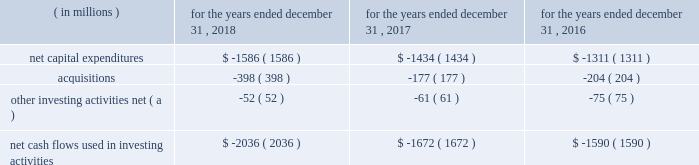In 2017 , cash flows provided by operations increased $ 160 million , primarily due to an increase in net income after non-cash adjustments , including the impact of the enactment of the tcja , and an increase in cash flows from working capital .
The main factors contributing to the net income increase are described in the 201cconsolidated results of operations 201d section and include higher operating revenues , partially offset by higher income taxes due to a $ 125 million re-measurement charge resulting from the impact of the change in the federal tax rate on the company 2019s deferred income taxes from the enactment of the tcja .
The increase in non-cash activities was mainly attributable to the increase in deferred income taxes , as mentioned above , and an increase in depreciation and amortization due to additional utility plant placed in service .
The change in working capital was principally due to ( i ) the timing of accounts payable and accrued liabilities , including the accrual recorded during 2016 for the binding global agreement in principle to settle claims associated with the freedom industries chemical spill in west virginia , ( ii ) a decrease in unbilled revenues as a result of our military services group achieving significant capital project milestones during 2016 , and ( iii ) a change in other current assets and liabilities , including the decrease in other current assets associated with the termination of our four forward starting swap agreements and timing of payments clearing our cash accounts .
The company expects to make pension contributions to the plan trusts of up to $ 31 million in 2019 .
In addition , we estimate that contributions will amount to $ 32 million , $ 29 million , $ 29 million and $ 29 million in 2020 , 2021 , 2022 and 2023 , respectively .
Actual amounts contributed could change materially from these estimates as a result of changes in assumptions and actual investment returns , among other factors .
Cash flows used in investing activities the table provides a summary of the major items affecting our cash flows used in investing activities: .
( a ) includes removal costs from property , plant and equipment retirements and proceeds from sale of assets .
In 2018 and 2017 , cash flows used in investing activities increased primarily due to an increase in our regulated capital expenditures , principally from incremental investments associated with the replacement and renewal of our transmission and distribution infrastructure in our regulated businesses , as well as acquisitions in both our regulated businesses and market-based businesses , as discussed below .
Our infrastructure investment plan consists of both infrastructure renewal programs , where we replace infrastructure , as needed , and major capital investment projects , where we construct new water and wastewater treatment and delivery facilities to meet new customer growth and water quality regulations .
Our projected capital expenditures and other investments are subject to periodic review and revision to reflect changes in economic conditions and other factors. .
What are expected pension contributions in millions for 2020 and 2021? 
Computations: (32 + 29)
Answer: 61.0. In 2017 , cash flows provided by operations increased $ 160 million , primarily due to an increase in net income after non-cash adjustments , including the impact of the enactment of the tcja , and an increase in cash flows from working capital .
The main factors contributing to the net income increase are described in the 201cconsolidated results of operations 201d section and include higher operating revenues , partially offset by higher income taxes due to a $ 125 million re-measurement charge resulting from the impact of the change in the federal tax rate on the company 2019s deferred income taxes from the enactment of the tcja .
The increase in non-cash activities was mainly attributable to the increase in deferred income taxes , as mentioned above , and an increase in depreciation and amortization due to additional utility plant placed in service .
The change in working capital was principally due to ( i ) the timing of accounts payable and accrued liabilities , including the accrual recorded during 2016 for the binding global agreement in principle to settle claims associated with the freedom industries chemical spill in west virginia , ( ii ) a decrease in unbilled revenues as a result of our military services group achieving significant capital project milestones during 2016 , and ( iii ) a change in other current assets and liabilities , including the decrease in other current assets associated with the termination of our four forward starting swap agreements and timing of payments clearing our cash accounts .
The company expects to make pension contributions to the plan trusts of up to $ 31 million in 2019 .
In addition , we estimate that contributions will amount to $ 32 million , $ 29 million , $ 29 million and $ 29 million in 2020 , 2021 , 2022 and 2023 , respectively .
Actual amounts contributed could change materially from these estimates as a result of changes in assumptions and actual investment returns , among other factors .
Cash flows used in investing activities the table provides a summary of the major items affecting our cash flows used in investing activities: .
( a ) includes removal costs from property , plant and equipment retirements and proceeds from sale of assets .
In 2018 and 2017 , cash flows used in investing activities increased primarily due to an increase in our regulated capital expenditures , principally from incremental investments associated with the replacement and renewal of our transmission and distribution infrastructure in our regulated businesses , as well as acquisitions in both our regulated businesses and market-based businesses , as discussed below .
Our infrastructure investment plan consists of both infrastructure renewal programs , where we replace infrastructure , as needed , and major capital investment projects , where we construct new water and wastewater treatment and delivery facilities to meet new customer growth and water quality regulations .
Our projected capital expenditures and other investments are subject to periodic review and revision to reflect changes in economic conditions and other factors. .
What were total net capital expenditures in millions for the three year period\\n? 
Computations: table_sum(net capital expenditures, none)
Answer: -4331.0. In 2017 , cash flows provided by operations increased $ 160 million , primarily due to an increase in net income after non-cash adjustments , including the impact of the enactment of the tcja , and an increase in cash flows from working capital .
The main factors contributing to the net income increase are described in the 201cconsolidated results of operations 201d section and include higher operating revenues , partially offset by higher income taxes due to a $ 125 million re-measurement charge resulting from the impact of the change in the federal tax rate on the company 2019s deferred income taxes from the enactment of the tcja .
The increase in non-cash activities was mainly attributable to the increase in deferred income taxes , as mentioned above , and an increase in depreciation and amortization due to additional utility plant placed in service .
The change in working capital was principally due to ( i ) the timing of accounts payable and accrued liabilities , including the accrual recorded during 2016 for the binding global agreement in principle to settle claims associated with the freedom industries chemical spill in west virginia , ( ii ) a decrease in unbilled revenues as a result of our military services group achieving significant capital project milestones during 2016 , and ( iii ) a change in other current assets and liabilities , including the decrease in other current assets associated with the termination of our four forward starting swap agreements and timing of payments clearing our cash accounts .
The company expects to make pension contributions to the plan trusts of up to $ 31 million in 2019 .
In addition , we estimate that contributions will amount to $ 32 million , $ 29 million , $ 29 million and $ 29 million in 2020 , 2021 , 2022 and 2023 , respectively .
Actual amounts contributed could change materially from these estimates as a result of changes in assumptions and actual investment returns , among other factors .
Cash flows used in investing activities the table provides a summary of the major items affecting our cash flows used in investing activities: .
( a ) includes removal costs from property , plant and equipment retirements and proceeds from sale of assets .
In 2018 and 2017 , cash flows used in investing activities increased primarily due to an increase in our regulated capital expenditures , principally from incremental investments associated with the replacement and renewal of our transmission and distribution infrastructure in our regulated businesses , as well as acquisitions in both our regulated businesses and market-based businesses , as discussed below .
Our infrastructure investment plan consists of both infrastructure renewal programs , where we replace infrastructure , as needed , and major capital investment projects , where we construct new water and wastewater treatment and delivery facilities to meet new customer growth and water quality regulations .
Our projected capital expenditures and other investments are subject to periodic review and revision to reflect changes in economic conditions and other factors. .
In 2018 , what percentage of cash flows used in investing activities composed of net capital expenditures? 
Computations: (1586 / 2036)
Answer: 0.77898. 